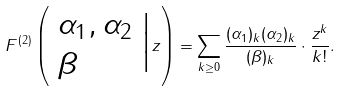Convert formula to latex. <formula><loc_0><loc_0><loc_500><loc_500>F ^ { ( 2 ) } \left ( \begin{array} { l } \alpha _ { 1 } , \alpha _ { 2 } \\ \beta \end{array} \Big | z \right ) = \sum _ { k \geq 0 } \frac { ( \alpha _ { 1 } ) _ { k } ( \alpha _ { 2 } ) _ { k } } { ( \beta ) _ { k } } \cdot \frac { z ^ { k } } { k ! } .</formula> 